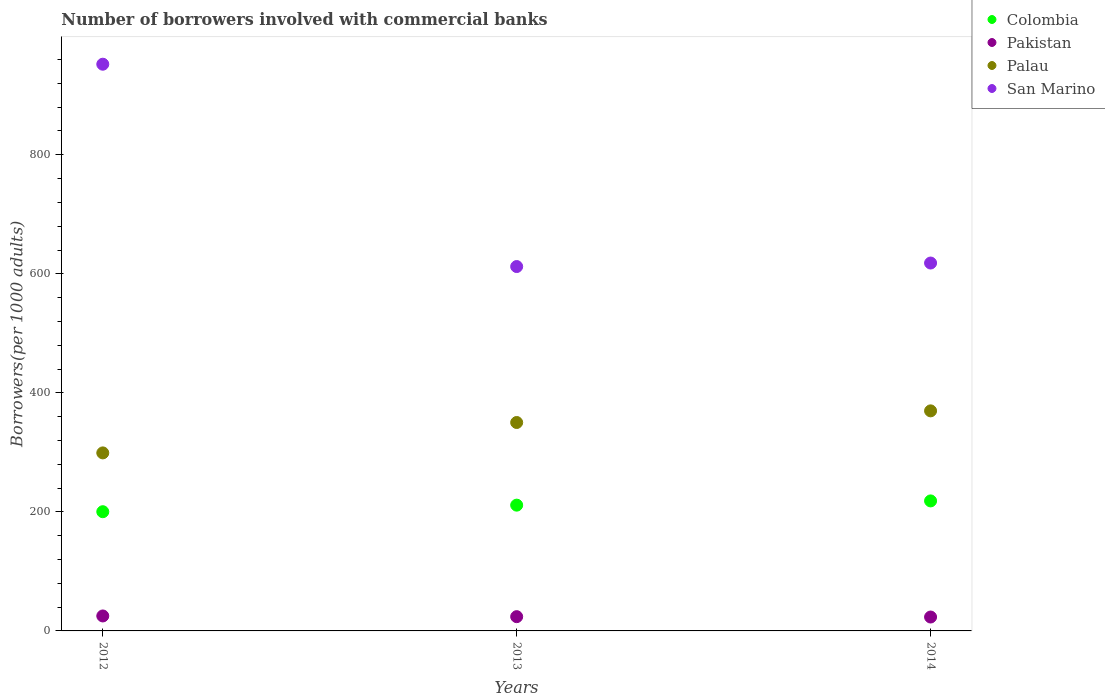How many different coloured dotlines are there?
Ensure brevity in your answer.  4. What is the number of borrowers involved with commercial banks in Palau in 2014?
Give a very brief answer. 369.74. Across all years, what is the maximum number of borrowers involved with commercial banks in Colombia?
Offer a very short reply. 218.44. Across all years, what is the minimum number of borrowers involved with commercial banks in Palau?
Your answer should be compact. 299.11. In which year was the number of borrowers involved with commercial banks in Pakistan maximum?
Make the answer very short. 2012. In which year was the number of borrowers involved with commercial banks in Pakistan minimum?
Your response must be concise. 2014. What is the total number of borrowers involved with commercial banks in Pakistan in the graph?
Your response must be concise. 72.45. What is the difference between the number of borrowers involved with commercial banks in Palau in 2012 and that in 2013?
Offer a very short reply. -51.07. What is the difference between the number of borrowers involved with commercial banks in Pakistan in 2013 and the number of borrowers involved with commercial banks in Colombia in 2012?
Offer a very short reply. -176.33. What is the average number of borrowers involved with commercial banks in San Marino per year?
Your response must be concise. 727.5. In the year 2014, what is the difference between the number of borrowers involved with commercial banks in Palau and number of borrowers involved with commercial banks in Colombia?
Offer a terse response. 151.3. What is the ratio of the number of borrowers involved with commercial banks in Pakistan in 2013 to that in 2014?
Ensure brevity in your answer.  1.03. Is the number of borrowers involved with commercial banks in Pakistan in 2013 less than that in 2014?
Your answer should be compact. No. Is the difference between the number of borrowers involved with commercial banks in Palau in 2012 and 2014 greater than the difference between the number of borrowers involved with commercial banks in Colombia in 2012 and 2014?
Make the answer very short. No. What is the difference between the highest and the second highest number of borrowers involved with commercial banks in Colombia?
Your answer should be very brief. 7.11. What is the difference between the highest and the lowest number of borrowers involved with commercial banks in Colombia?
Your answer should be very brief. 18.14. Is the sum of the number of borrowers involved with commercial banks in Colombia in 2012 and 2013 greater than the maximum number of borrowers involved with commercial banks in San Marino across all years?
Your answer should be very brief. No. Is it the case that in every year, the sum of the number of borrowers involved with commercial banks in Palau and number of borrowers involved with commercial banks in Pakistan  is greater than the number of borrowers involved with commercial banks in Colombia?
Make the answer very short. Yes. Does the number of borrowers involved with commercial banks in Palau monotonically increase over the years?
Your response must be concise. Yes. Is the number of borrowers involved with commercial banks in Palau strictly greater than the number of borrowers involved with commercial banks in San Marino over the years?
Offer a terse response. No. Is the number of borrowers involved with commercial banks in San Marino strictly less than the number of borrowers involved with commercial banks in Palau over the years?
Offer a very short reply. No. How many dotlines are there?
Your response must be concise. 4. How many years are there in the graph?
Give a very brief answer. 3. Are the values on the major ticks of Y-axis written in scientific E-notation?
Your answer should be compact. No. Does the graph contain any zero values?
Ensure brevity in your answer.  No. Does the graph contain grids?
Offer a terse response. No. Where does the legend appear in the graph?
Make the answer very short. Top right. How many legend labels are there?
Offer a terse response. 4. How are the legend labels stacked?
Provide a succinct answer. Vertical. What is the title of the graph?
Provide a short and direct response. Number of borrowers involved with commercial banks. What is the label or title of the Y-axis?
Offer a very short reply. Borrowers(per 1000 adults). What is the Borrowers(per 1000 adults) of Colombia in 2012?
Your answer should be compact. 200.29. What is the Borrowers(per 1000 adults) in Pakistan in 2012?
Your answer should be compact. 25.15. What is the Borrowers(per 1000 adults) in Palau in 2012?
Make the answer very short. 299.11. What is the Borrowers(per 1000 adults) in San Marino in 2012?
Make the answer very short. 952.16. What is the Borrowers(per 1000 adults) in Colombia in 2013?
Your answer should be very brief. 211.32. What is the Borrowers(per 1000 adults) in Pakistan in 2013?
Your answer should be very brief. 23.97. What is the Borrowers(per 1000 adults) in Palau in 2013?
Give a very brief answer. 350.18. What is the Borrowers(per 1000 adults) of San Marino in 2013?
Your answer should be compact. 612.21. What is the Borrowers(per 1000 adults) of Colombia in 2014?
Your answer should be compact. 218.44. What is the Borrowers(per 1000 adults) of Pakistan in 2014?
Provide a short and direct response. 23.34. What is the Borrowers(per 1000 adults) of Palau in 2014?
Offer a terse response. 369.74. What is the Borrowers(per 1000 adults) of San Marino in 2014?
Ensure brevity in your answer.  618.11. Across all years, what is the maximum Borrowers(per 1000 adults) of Colombia?
Offer a very short reply. 218.44. Across all years, what is the maximum Borrowers(per 1000 adults) of Pakistan?
Provide a succinct answer. 25.15. Across all years, what is the maximum Borrowers(per 1000 adults) of Palau?
Provide a succinct answer. 369.74. Across all years, what is the maximum Borrowers(per 1000 adults) in San Marino?
Provide a short and direct response. 952.16. Across all years, what is the minimum Borrowers(per 1000 adults) of Colombia?
Offer a terse response. 200.29. Across all years, what is the minimum Borrowers(per 1000 adults) in Pakistan?
Your answer should be compact. 23.34. Across all years, what is the minimum Borrowers(per 1000 adults) of Palau?
Offer a terse response. 299.11. Across all years, what is the minimum Borrowers(per 1000 adults) of San Marino?
Provide a short and direct response. 612.21. What is the total Borrowers(per 1000 adults) in Colombia in the graph?
Give a very brief answer. 630.05. What is the total Borrowers(per 1000 adults) of Pakistan in the graph?
Offer a terse response. 72.45. What is the total Borrowers(per 1000 adults) in Palau in the graph?
Offer a terse response. 1019.02. What is the total Borrowers(per 1000 adults) in San Marino in the graph?
Your answer should be compact. 2182.49. What is the difference between the Borrowers(per 1000 adults) of Colombia in 2012 and that in 2013?
Provide a short and direct response. -11.03. What is the difference between the Borrowers(per 1000 adults) in Pakistan in 2012 and that in 2013?
Offer a terse response. 1.18. What is the difference between the Borrowers(per 1000 adults) in Palau in 2012 and that in 2013?
Keep it short and to the point. -51.07. What is the difference between the Borrowers(per 1000 adults) of San Marino in 2012 and that in 2013?
Offer a terse response. 339.95. What is the difference between the Borrowers(per 1000 adults) of Colombia in 2012 and that in 2014?
Give a very brief answer. -18.14. What is the difference between the Borrowers(per 1000 adults) in Pakistan in 2012 and that in 2014?
Provide a succinct answer. 1.81. What is the difference between the Borrowers(per 1000 adults) in Palau in 2012 and that in 2014?
Make the answer very short. -70.63. What is the difference between the Borrowers(per 1000 adults) in San Marino in 2012 and that in 2014?
Provide a short and direct response. 334.05. What is the difference between the Borrowers(per 1000 adults) of Colombia in 2013 and that in 2014?
Offer a very short reply. -7.11. What is the difference between the Borrowers(per 1000 adults) in Pakistan in 2013 and that in 2014?
Give a very brief answer. 0.63. What is the difference between the Borrowers(per 1000 adults) in Palau in 2013 and that in 2014?
Keep it short and to the point. -19.56. What is the difference between the Borrowers(per 1000 adults) in San Marino in 2013 and that in 2014?
Make the answer very short. -5.9. What is the difference between the Borrowers(per 1000 adults) in Colombia in 2012 and the Borrowers(per 1000 adults) in Pakistan in 2013?
Offer a very short reply. 176.33. What is the difference between the Borrowers(per 1000 adults) of Colombia in 2012 and the Borrowers(per 1000 adults) of Palau in 2013?
Provide a succinct answer. -149.89. What is the difference between the Borrowers(per 1000 adults) of Colombia in 2012 and the Borrowers(per 1000 adults) of San Marino in 2013?
Offer a terse response. -411.92. What is the difference between the Borrowers(per 1000 adults) of Pakistan in 2012 and the Borrowers(per 1000 adults) of Palau in 2013?
Give a very brief answer. -325.03. What is the difference between the Borrowers(per 1000 adults) of Pakistan in 2012 and the Borrowers(per 1000 adults) of San Marino in 2013?
Provide a short and direct response. -587.06. What is the difference between the Borrowers(per 1000 adults) of Palau in 2012 and the Borrowers(per 1000 adults) of San Marino in 2013?
Offer a terse response. -313.1. What is the difference between the Borrowers(per 1000 adults) of Colombia in 2012 and the Borrowers(per 1000 adults) of Pakistan in 2014?
Keep it short and to the point. 176.95. What is the difference between the Borrowers(per 1000 adults) in Colombia in 2012 and the Borrowers(per 1000 adults) in Palau in 2014?
Offer a terse response. -169.44. What is the difference between the Borrowers(per 1000 adults) of Colombia in 2012 and the Borrowers(per 1000 adults) of San Marino in 2014?
Provide a succinct answer. -417.82. What is the difference between the Borrowers(per 1000 adults) in Pakistan in 2012 and the Borrowers(per 1000 adults) in Palau in 2014?
Keep it short and to the point. -344.59. What is the difference between the Borrowers(per 1000 adults) of Pakistan in 2012 and the Borrowers(per 1000 adults) of San Marino in 2014?
Your answer should be compact. -592.97. What is the difference between the Borrowers(per 1000 adults) in Palau in 2012 and the Borrowers(per 1000 adults) in San Marino in 2014?
Give a very brief answer. -319.01. What is the difference between the Borrowers(per 1000 adults) in Colombia in 2013 and the Borrowers(per 1000 adults) in Pakistan in 2014?
Your response must be concise. 187.98. What is the difference between the Borrowers(per 1000 adults) of Colombia in 2013 and the Borrowers(per 1000 adults) of Palau in 2014?
Your answer should be very brief. -158.42. What is the difference between the Borrowers(per 1000 adults) of Colombia in 2013 and the Borrowers(per 1000 adults) of San Marino in 2014?
Make the answer very short. -406.79. What is the difference between the Borrowers(per 1000 adults) in Pakistan in 2013 and the Borrowers(per 1000 adults) in Palau in 2014?
Offer a very short reply. -345.77. What is the difference between the Borrowers(per 1000 adults) of Pakistan in 2013 and the Borrowers(per 1000 adults) of San Marino in 2014?
Provide a succinct answer. -594.15. What is the difference between the Borrowers(per 1000 adults) of Palau in 2013 and the Borrowers(per 1000 adults) of San Marino in 2014?
Ensure brevity in your answer.  -267.93. What is the average Borrowers(per 1000 adults) in Colombia per year?
Your answer should be very brief. 210.02. What is the average Borrowers(per 1000 adults) of Pakistan per year?
Give a very brief answer. 24.15. What is the average Borrowers(per 1000 adults) in Palau per year?
Your answer should be very brief. 339.67. What is the average Borrowers(per 1000 adults) of San Marino per year?
Your response must be concise. 727.5. In the year 2012, what is the difference between the Borrowers(per 1000 adults) in Colombia and Borrowers(per 1000 adults) in Pakistan?
Provide a short and direct response. 175.15. In the year 2012, what is the difference between the Borrowers(per 1000 adults) of Colombia and Borrowers(per 1000 adults) of Palau?
Offer a very short reply. -98.81. In the year 2012, what is the difference between the Borrowers(per 1000 adults) of Colombia and Borrowers(per 1000 adults) of San Marino?
Make the answer very short. -751.87. In the year 2012, what is the difference between the Borrowers(per 1000 adults) of Pakistan and Borrowers(per 1000 adults) of Palau?
Provide a short and direct response. -273.96. In the year 2012, what is the difference between the Borrowers(per 1000 adults) of Pakistan and Borrowers(per 1000 adults) of San Marino?
Make the answer very short. -927.01. In the year 2012, what is the difference between the Borrowers(per 1000 adults) in Palau and Borrowers(per 1000 adults) in San Marino?
Offer a terse response. -653.05. In the year 2013, what is the difference between the Borrowers(per 1000 adults) of Colombia and Borrowers(per 1000 adults) of Pakistan?
Your answer should be very brief. 187.36. In the year 2013, what is the difference between the Borrowers(per 1000 adults) in Colombia and Borrowers(per 1000 adults) in Palau?
Offer a very short reply. -138.86. In the year 2013, what is the difference between the Borrowers(per 1000 adults) in Colombia and Borrowers(per 1000 adults) in San Marino?
Offer a very short reply. -400.89. In the year 2013, what is the difference between the Borrowers(per 1000 adults) of Pakistan and Borrowers(per 1000 adults) of Palau?
Your response must be concise. -326.21. In the year 2013, what is the difference between the Borrowers(per 1000 adults) in Pakistan and Borrowers(per 1000 adults) in San Marino?
Provide a succinct answer. -588.25. In the year 2013, what is the difference between the Borrowers(per 1000 adults) in Palau and Borrowers(per 1000 adults) in San Marino?
Make the answer very short. -262.03. In the year 2014, what is the difference between the Borrowers(per 1000 adults) of Colombia and Borrowers(per 1000 adults) of Pakistan?
Provide a succinct answer. 195.1. In the year 2014, what is the difference between the Borrowers(per 1000 adults) of Colombia and Borrowers(per 1000 adults) of Palau?
Your answer should be very brief. -151.3. In the year 2014, what is the difference between the Borrowers(per 1000 adults) in Colombia and Borrowers(per 1000 adults) in San Marino?
Your answer should be compact. -399.68. In the year 2014, what is the difference between the Borrowers(per 1000 adults) of Pakistan and Borrowers(per 1000 adults) of Palau?
Your answer should be very brief. -346.4. In the year 2014, what is the difference between the Borrowers(per 1000 adults) in Pakistan and Borrowers(per 1000 adults) in San Marino?
Give a very brief answer. -594.77. In the year 2014, what is the difference between the Borrowers(per 1000 adults) of Palau and Borrowers(per 1000 adults) of San Marino?
Offer a terse response. -248.38. What is the ratio of the Borrowers(per 1000 adults) in Colombia in 2012 to that in 2013?
Your answer should be compact. 0.95. What is the ratio of the Borrowers(per 1000 adults) of Pakistan in 2012 to that in 2013?
Give a very brief answer. 1.05. What is the ratio of the Borrowers(per 1000 adults) in Palau in 2012 to that in 2013?
Your response must be concise. 0.85. What is the ratio of the Borrowers(per 1000 adults) of San Marino in 2012 to that in 2013?
Give a very brief answer. 1.56. What is the ratio of the Borrowers(per 1000 adults) in Colombia in 2012 to that in 2014?
Offer a terse response. 0.92. What is the ratio of the Borrowers(per 1000 adults) in Pakistan in 2012 to that in 2014?
Provide a succinct answer. 1.08. What is the ratio of the Borrowers(per 1000 adults) in Palau in 2012 to that in 2014?
Ensure brevity in your answer.  0.81. What is the ratio of the Borrowers(per 1000 adults) in San Marino in 2012 to that in 2014?
Your answer should be very brief. 1.54. What is the ratio of the Borrowers(per 1000 adults) of Colombia in 2013 to that in 2014?
Provide a succinct answer. 0.97. What is the ratio of the Borrowers(per 1000 adults) of Pakistan in 2013 to that in 2014?
Your answer should be compact. 1.03. What is the ratio of the Borrowers(per 1000 adults) in Palau in 2013 to that in 2014?
Your answer should be compact. 0.95. What is the difference between the highest and the second highest Borrowers(per 1000 adults) of Colombia?
Your response must be concise. 7.11. What is the difference between the highest and the second highest Borrowers(per 1000 adults) of Pakistan?
Make the answer very short. 1.18. What is the difference between the highest and the second highest Borrowers(per 1000 adults) in Palau?
Give a very brief answer. 19.56. What is the difference between the highest and the second highest Borrowers(per 1000 adults) in San Marino?
Your answer should be very brief. 334.05. What is the difference between the highest and the lowest Borrowers(per 1000 adults) in Colombia?
Your answer should be compact. 18.14. What is the difference between the highest and the lowest Borrowers(per 1000 adults) of Pakistan?
Your answer should be very brief. 1.81. What is the difference between the highest and the lowest Borrowers(per 1000 adults) of Palau?
Your answer should be very brief. 70.63. What is the difference between the highest and the lowest Borrowers(per 1000 adults) of San Marino?
Your response must be concise. 339.95. 